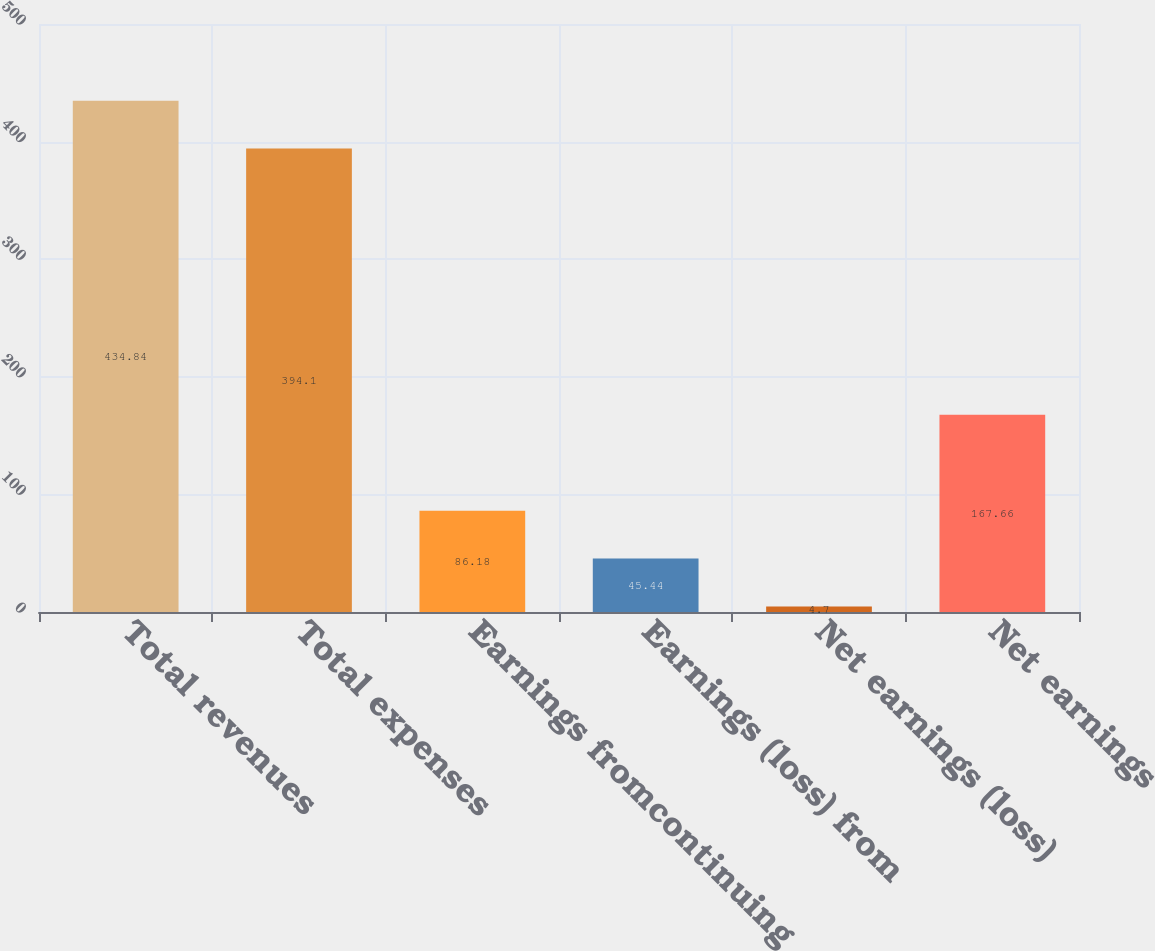<chart> <loc_0><loc_0><loc_500><loc_500><bar_chart><fcel>Total revenues<fcel>Total expenses<fcel>Earnings fromcontinuing<fcel>Earnings (loss) from<fcel>Net earnings (loss)<fcel>Net earnings<nl><fcel>434.84<fcel>394.1<fcel>86.18<fcel>45.44<fcel>4.7<fcel>167.66<nl></chart> 